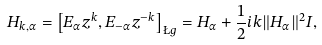<formula> <loc_0><loc_0><loc_500><loc_500>H _ { k , \alpha } = \left [ E _ { \alpha } z ^ { k } , E _ { - \alpha } z ^ { - k } \right ] _ { \L g } = H _ { \alpha } + \frac { 1 } { 2 } i k \| H _ { \alpha } \| ^ { 2 } I ,</formula> 